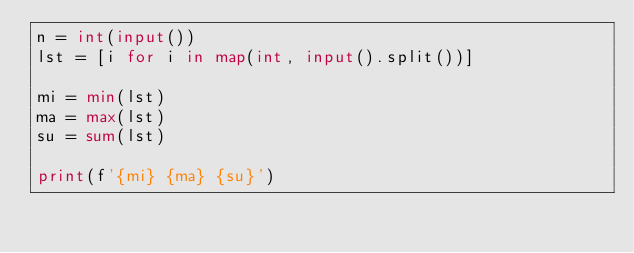Convert code to text. <code><loc_0><loc_0><loc_500><loc_500><_Python_>n = int(input())
lst = [i for i in map(int, input().split())]

mi = min(lst)
ma = max(lst)
su = sum(lst)

print(f'{mi} {ma} {su}')
</code> 